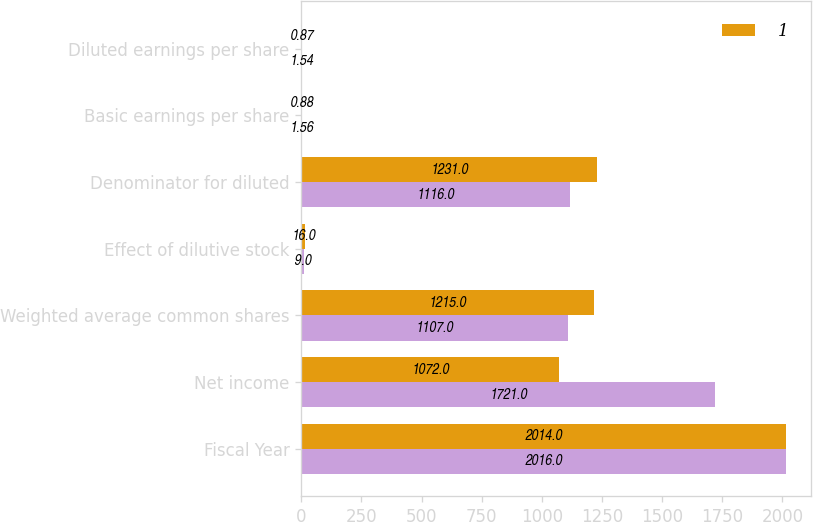Convert chart to OTSL. <chart><loc_0><loc_0><loc_500><loc_500><stacked_bar_chart><ecel><fcel>Fiscal Year<fcel>Net income<fcel>Weighted average common shares<fcel>Effect of dilutive stock<fcel>Denominator for diluted<fcel>Basic earnings per share<fcel>Diluted earnings per share<nl><fcel>nan<fcel>2016<fcel>1721<fcel>1107<fcel>9<fcel>1116<fcel>1.56<fcel>1.54<nl><fcel>1<fcel>2014<fcel>1072<fcel>1215<fcel>16<fcel>1231<fcel>0.88<fcel>0.87<nl></chart> 